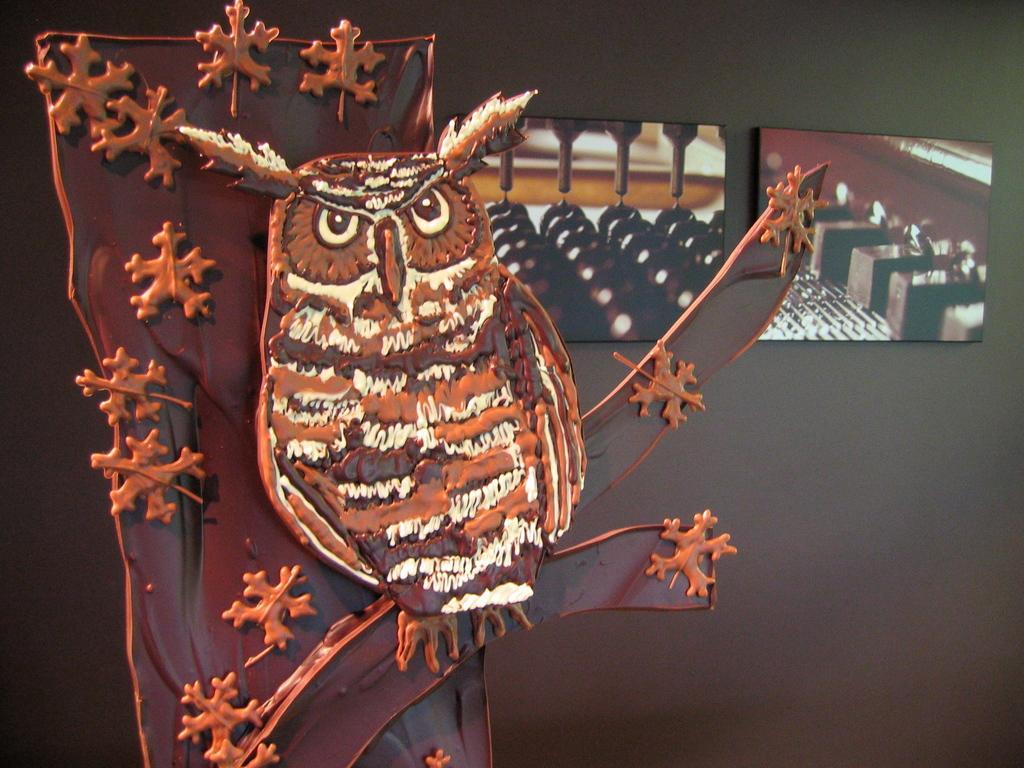Describe this image in one or two sentences. In the image there is a depiction of an owl sitting on a tree and in the background there is a wall, in front of the wall there are two photo frames. 